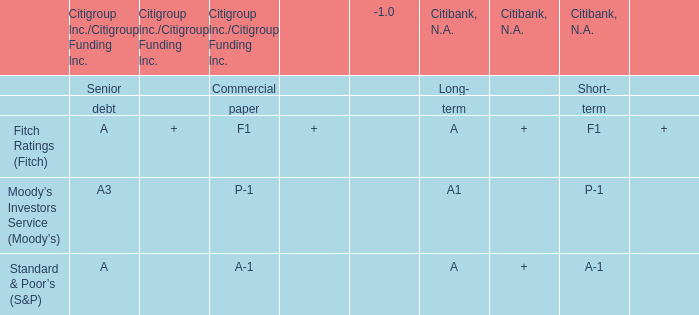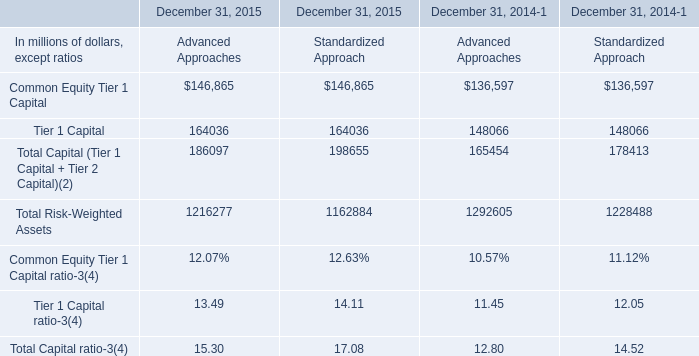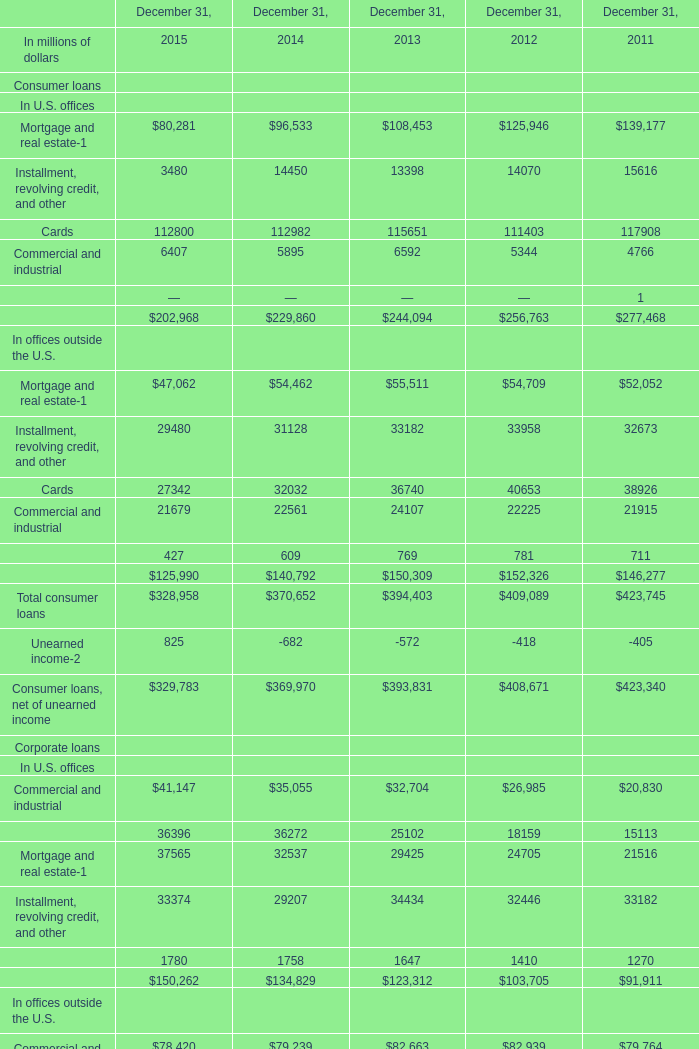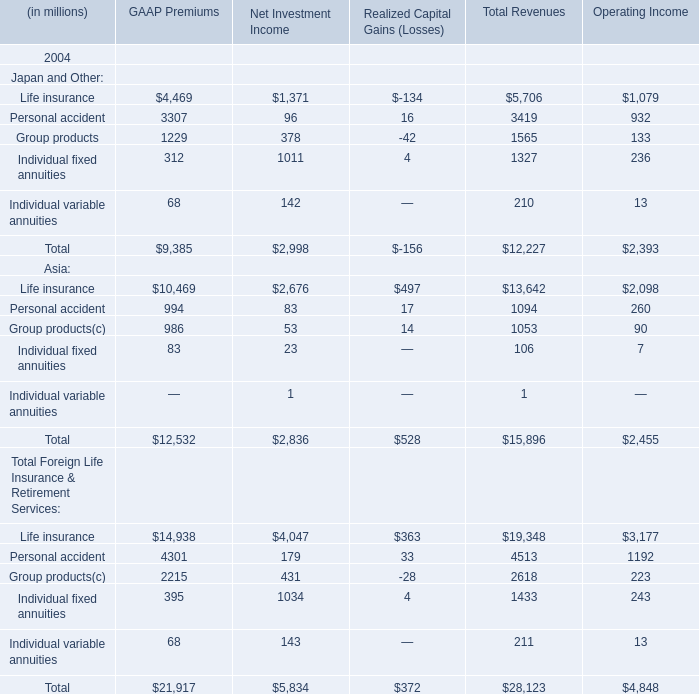What was the average value of Mortgage and real estate, Cards, Installment, revolving credit and other in 2015 for consumer loans outside the U.S. offices ? (in million) 
Computations: (((47062 + 29480) + 27342) / 3)
Answer: 34628.0. 